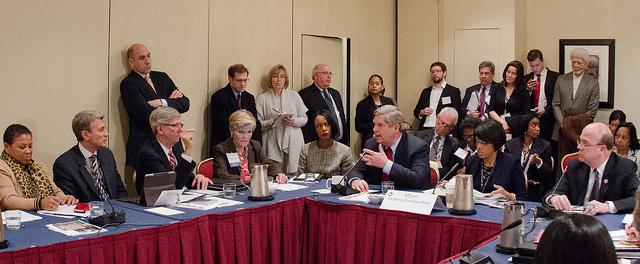Why are some people standing?
Be succinct. No more seats. What is happening in this room?
Short answer required. Meeting. Is this a business meeting?
Short answer required. Yes. Are there a lot of people in the room?
Give a very brief answer. Yes. 